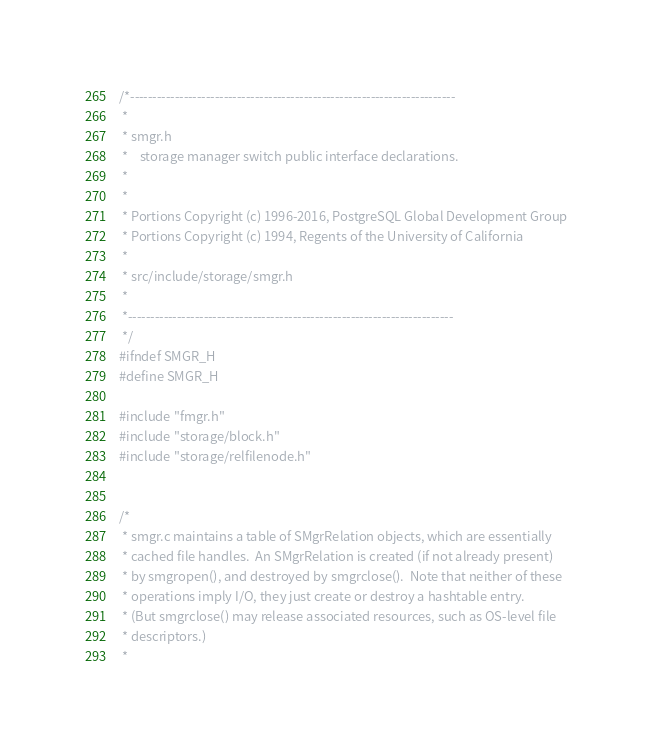Convert code to text. <code><loc_0><loc_0><loc_500><loc_500><_C_>/*-------------------------------------------------------------------------
 *
 * smgr.h
 *	  storage manager switch public interface declarations.
 *
 *
 * Portions Copyright (c) 1996-2016, PostgreSQL Global Development Group
 * Portions Copyright (c) 1994, Regents of the University of California
 *
 * src/include/storage/smgr.h
 *
 *-------------------------------------------------------------------------
 */
#ifndef SMGR_H
#define SMGR_H

#include "fmgr.h"
#include "storage/block.h"
#include "storage/relfilenode.h"


/*
 * smgr.c maintains a table of SMgrRelation objects, which are essentially
 * cached file handles.  An SMgrRelation is created (if not already present)
 * by smgropen(), and destroyed by smgrclose().  Note that neither of these
 * operations imply I/O, they just create or destroy a hashtable entry.
 * (But smgrclose() may release associated resources, such as OS-level file
 * descriptors.)
 *</code> 